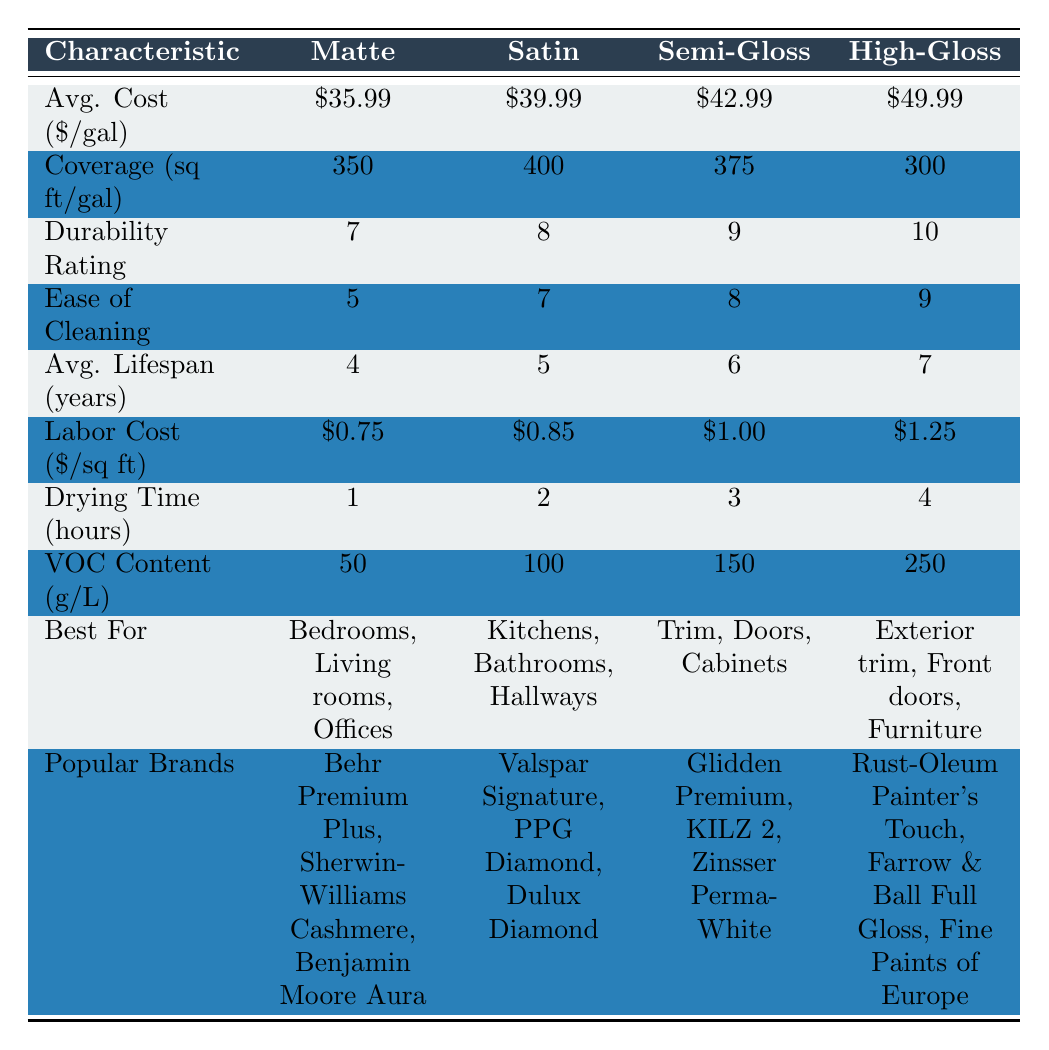What is the average cost per gallon of matte paint? The table lists the average cost per gallon of matte paint as $35.99.
Answer: $35.99 Which finish has the highest durability rating? From the durability ratings in the table, high-gloss paint has the highest rating of 10.
Answer: High-gloss How much more does high-gloss paint cost per gallon compared to matte paint? The cost of high-gloss paint is $49.99, and matte paint is $35.99. The difference is $49.99 - $35.99 = $14.00.
Answer: $14.00 Is satin paint the best choice for living rooms? According to the table, satin paint is best for kitchens, bathrooms, and hallways, not living rooms, which are best for matte paint. Thus, the statement is false.
Answer: No What is the total coverage area per gallon of satin and semi-gloss paints combined? Satin covers 400 sq ft per gallon and semi-gloss covers 375 sq ft per gallon. Summing them gives 400 + 375 = 775 sq ft.
Answer: 775 sq ft Which paint finish has the fastest drying time? From the drying time data, matte paint dries the fastest in 1 hour.
Answer: Matte Does high-gloss paint have the highest VOC content? The VOC content for high-gloss paint is 250 g/L, which is higher than all the other finishes listed.
Answer: Yes What is the average lifespan of satin paint compared to matte paint? The average lifespan of satin paint is 5 years, while matte paint has an average lifespan of 4 years. Satin paint lasts 1 year longer than matte paint.
Answer: 1 year longer 